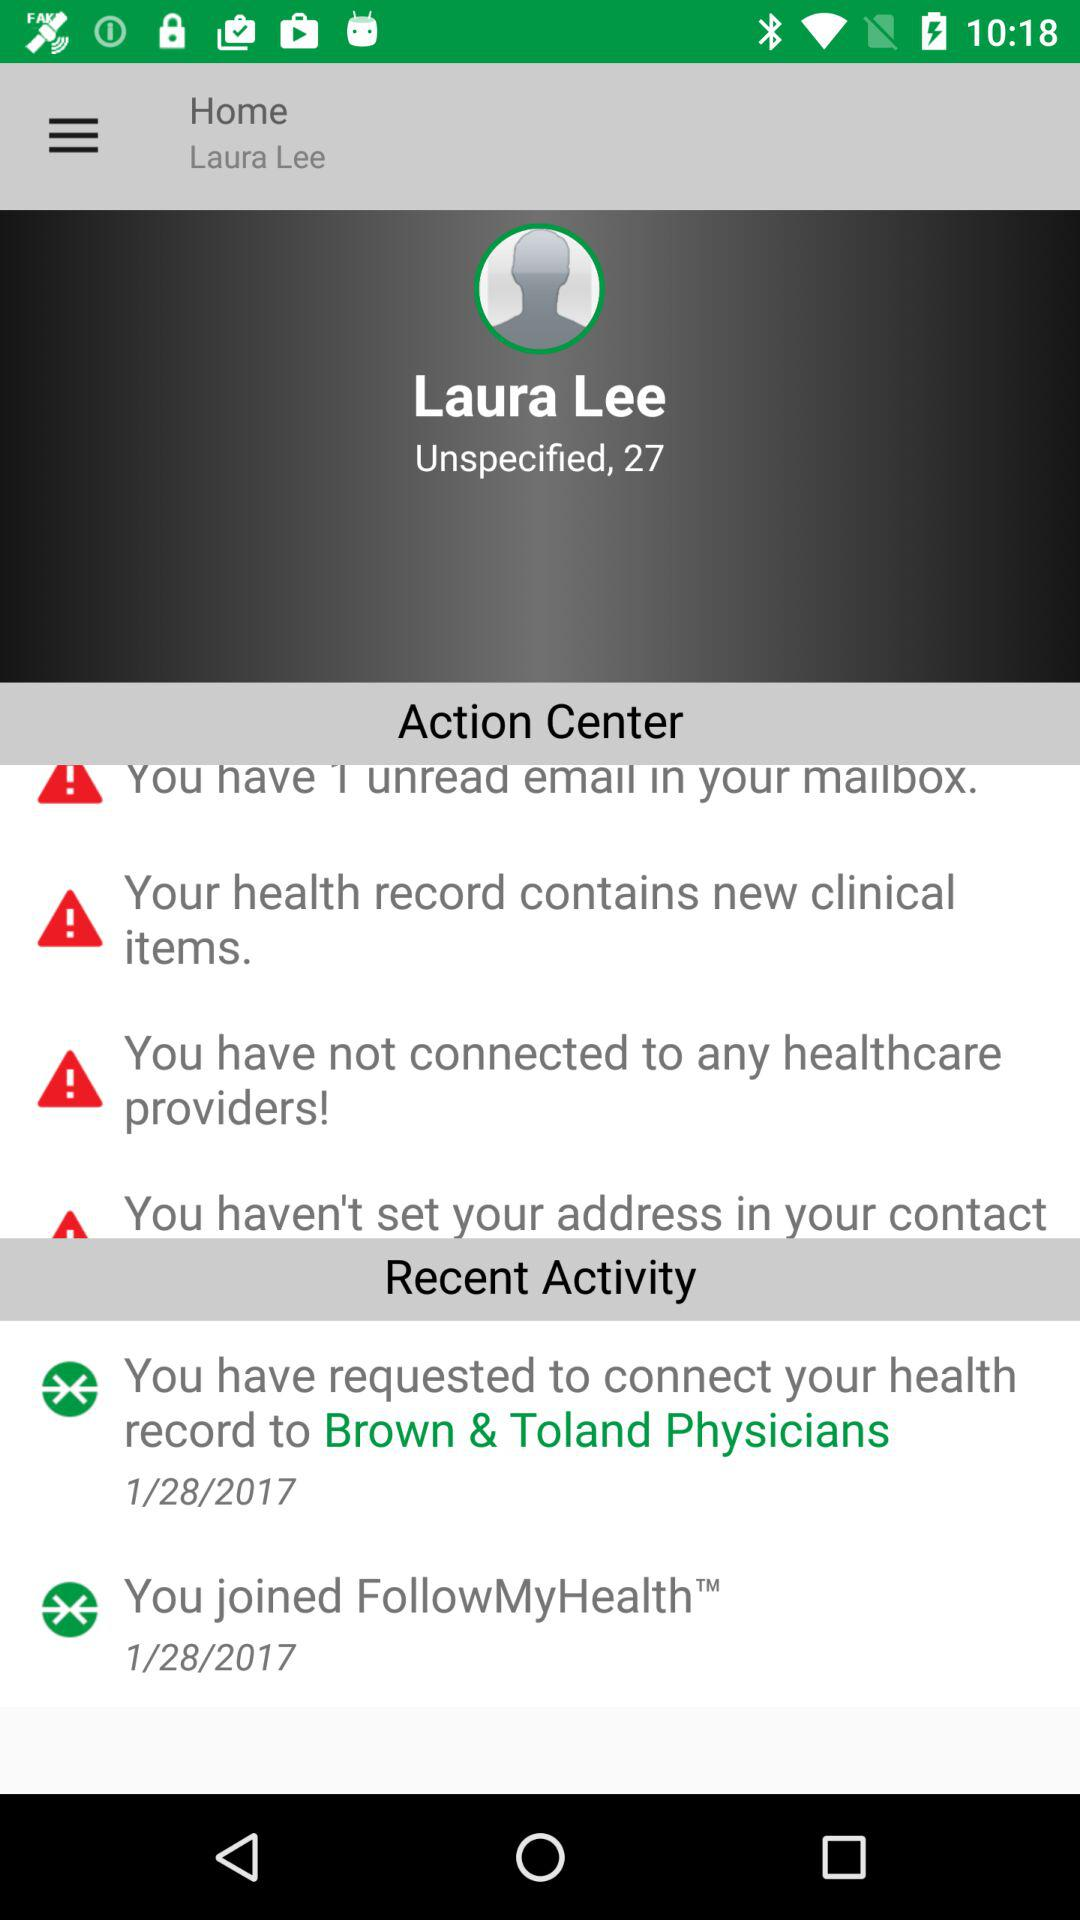What is the age of the user? The age of the user is 27. 